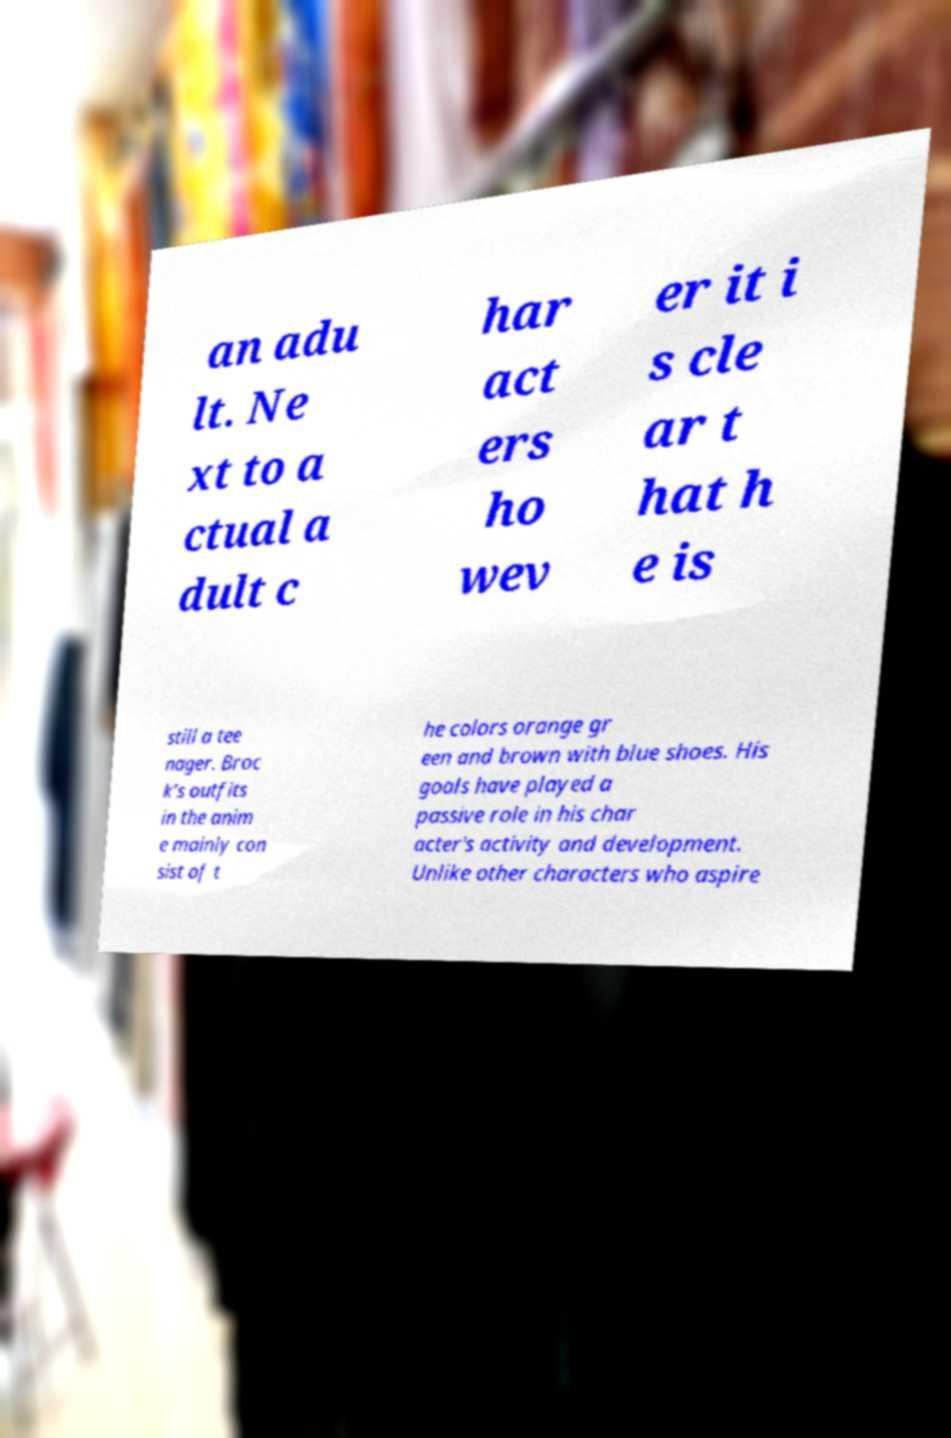For documentation purposes, I need the text within this image transcribed. Could you provide that? an adu lt. Ne xt to a ctual a dult c har act ers ho wev er it i s cle ar t hat h e is still a tee nager. Broc k’s outfits in the anim e mainly con sist of t he colors orange gr een and brown with blue shoes. His goals have played a passive role in his char acter's activity and development. Unlike other characters who aspire 